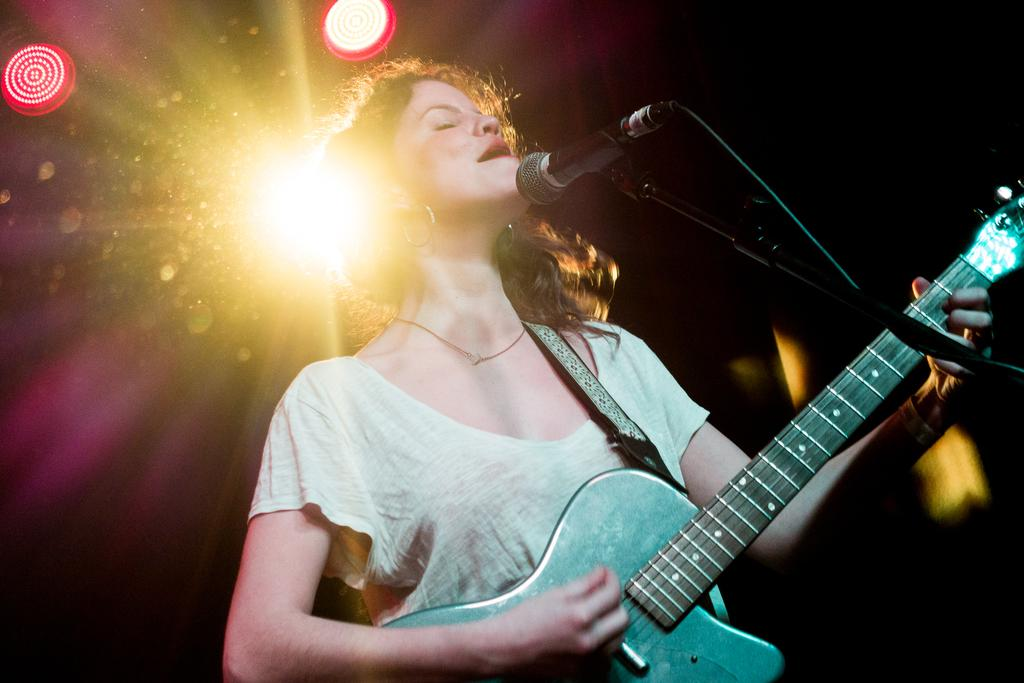Who is the main subject in the image? There is a woman in the image. What is the woman wearing? The woman is wearing a white dress. What is the woman doing in the image? The woman is playing a guitar. What object is present that might be used for amplifying her voice? There is a microphone in the image. What type of disease can be seen affecting the woman in the image? There is no disease present in the image; the woman appears to be healthy and playing a guitar. 